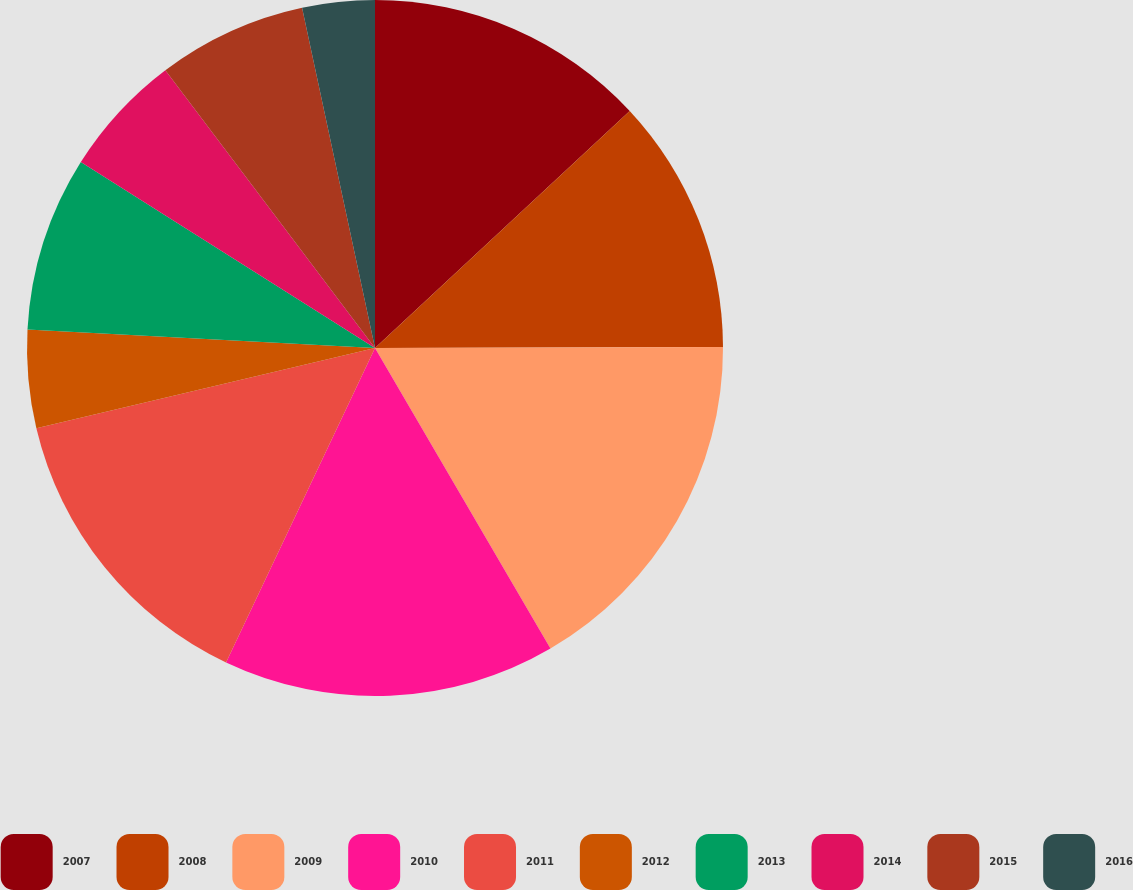Convert chart to OTSL. <chart><loc_0><loc_0><loc_500><loc_500><pie_chart><fcel>2007<fcel>2008<fcel>2009<fcel>2010<fcel>2011<fcel>2012<fcel>2013<fcel>2014<fcel>2015<fcel>2016<nl><fcel>13.07%<fcel>11.88%<fcel>16.64%<fcel>15.45%<fcel>14.26%<fcel>4.55%<fcel>8.12%<fcel>5.74%<fcel>6.93%<fcel>3.36%<nl></chart> 